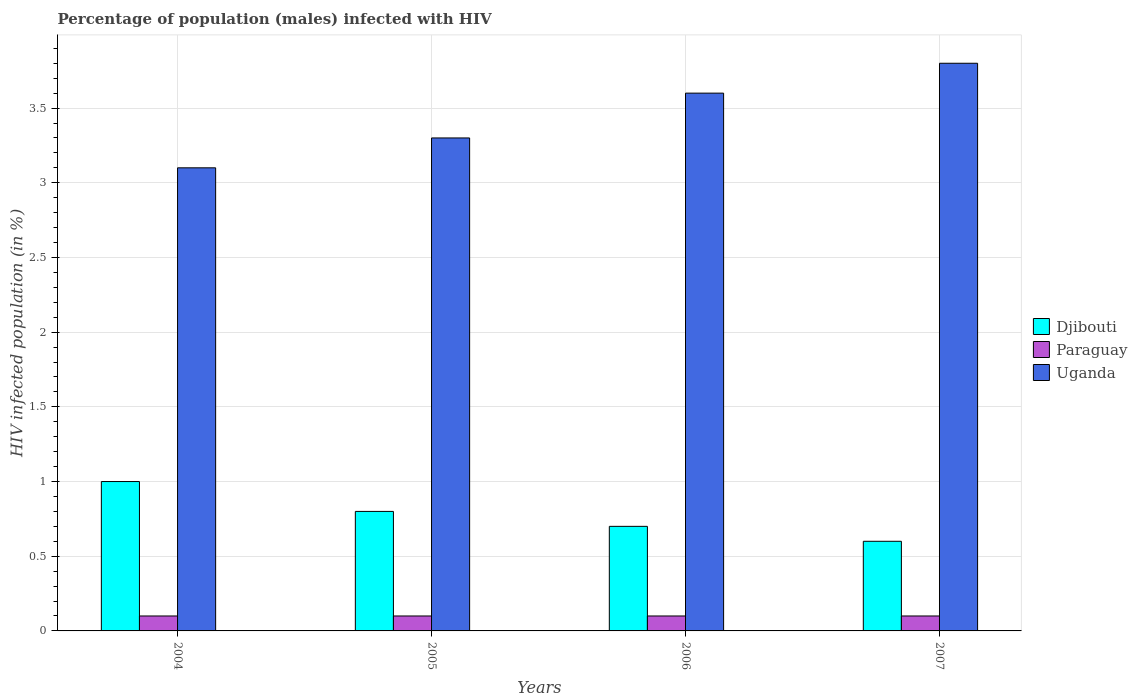How many groups of bars are there?
Provide a succinct answer. 4. How many bars are there on the 3rd tick from the left?
Ensure brevity in your answer.  3. How many bars are there on the 1st tick from the right?
Give a very brief answer. 3. In how many cases, is the number of bars for a given year not equal to the number of legend labels?
Offer a very short reply. 0. Across all years, what is the minimum percentage of HIV infected male population in Uganda?
Make the answer very short. 3.1. What is the difference between the percentage of HIV infected male population in Djibouti in 2004 and that in 2005?
Give a very brief answer. 0.2. What is the difference between the percentage of HIV infected male population in Uganda in 2007 and the percentage of HIV infected male population in Djibouti in 2006?
Ensure brevity in your answer.  3.1. What is the average percentage of HIV infected male population in Paraguay per year?
Offer a terse response. 0.1. What is the ratio of the percentage of HIV infected male population in Djibouti in 2004 to that in 2005?
Ensure brevity in your answer.  1.25. What is the difference between the highest and the second highest percentage of HIV infected male population in Djibouti?
Offer a very short reply. 0.2. What is the difference between the highest and the lowest percentage of HIV infected male population in Paraguay?
Ensure brevity in your answer.  0. In how many years, is the percentage of HIV infected male population in Paraguay greater than the average percentage of HIV infected male population in Paraguay taken over all years?
Ensure brevity in your answer.  0. Is the sum of the percentage of HIV infected male population in Djibouti in 2005 and 2006 greater than the maximum percentage of HIV infected male population in Paraguay across all years?
Your response must be concise. Yes. What does the 2nd bar from the left in 2007 represents?
Your response must be concise. Paraguay. What does the 2nd bar from the right in 2007 represents?
Keep it short and to the point. Paraguay. Is it the case that in every year, the sum of the percentage of HIV infected male population in Paraguay and percentage of HIV infected male population in Djibouti is greater than the percentage of HIV infected male population in Uganda?
Make the answer very short. No. How many bars are there?
Your answer should be very brief. 12. Are all the bars in the graph horizontal?
Offer a terse response. No. Are the values on the major ticks of Y-axis written in scientific E-notation?
Keep it short and to the point. No. Does the graph contain grids?
Your answer should be very brief. Yes. How are the legend labels stacked?
Provide a succinct answer. Vertical. What is the title of the graph?
Offer a terse response. Percentage of population (males) infected with HIV. Does "Bolivia" appear as one of the legend labels in the graph?
Your answer should be compact. No. What is the label or title of the Y-axis?
Provide a succinct answer. HIV infected population (in %). What is the HIV infected population (in %) of Djibouti in 2004?
Offer a very short reply. 1. What is the HIV infected population (in %) in Paraguay in 2004?
Offer a terse response. 0.1. What is the HIV infected population (in %) in Uganda in 2004?
Provide a short and direct response. 3.1. What is the HIV infected population (in %) in Paraguay in 2007?
Give a very brief answer. 0.1. What is the HIV infected population (in %) of Uganda in 2007?
Ensure brevity in your answer.  3.8. Across all years, what is the maximum HIV infected population (in %) of Djibouti?
Make the answer very short. 1. Across all years, what is the maximum HIV infected population (in %) of Paraguay?
Your answer should be compact. 0.1. Across all years, what is the minimum HIV infected population (in %) of Djibouti?
Your answer should be very brief. 0.6. What is the total HIV infected population (in %) in Djibouti in the graph?
Offer a terse response. 3.1. What is the total HIV infected population (in %) of Paraguay in the graph?
Offer a terse response. 0.4. What is the difference between the HIV infected population (in %) in Uganda in 2004 and that in 2005?
Keep it short and to the point. -0.2. What is the difference between the HIV infected population (in %) in Djibouti in 2004 and that in 2006?
Your answer should be very brief. 0.3. What is the difference between the HIV infected population (in %) of Paraguay in 2004 and that in 2006?
Ensure brevity in your answer.  0. What is the difference between the HIV infected population (in %) of Uganda in 2004 and that in 2006?
Your answer should be very brief. -0.5. What is the difference between the HIV infected population (in %) in Djibouti in 2004 and that in 2007?
Provide a short and direct response. 0.4. What is the difference between the HIV infected population (in %) of Uganda in 2004 and that in 2007?
Your answer should be very brief. -0.7. What is the difference between the HIV infected population (in %) of Paraguay in 2005 and that in 2006?
Give a very brief answer. 0. What is the difference between the HIV infected population (in %) of Uganda in 2005 and that in 2006?
Provide a succinct answer. -0.3. What is the difference between the HIV infected population (in %) of Djibouti in 2005 and that in 2007?
Ensure brevity in your answer.  0.2. What is the difference between the HIV infected population (in %) of Djibouti in 2006 and that in 2007?
Offer a terse response. 0.1. What is the difference between the HIV infected population (in %) of Uganda in 2006 and that in 2007?
Offer a very short reply. -0.2. What is the difference between the HIV infected population (in %) in Djibouti in 2004 and the HIV infected population (in %) in Paraguay in 2005?
Provide a succinct answer. 0.9. What is the difference between the HIV infected population (in %) in Djibouti in 2004 and the HIV infected population (in %) in Uganda in 2005?
Make the answer very short. -2.3. What is the difference between the HIV infected population (in %) of Djibouti in 2004 and the HIV infected population (in %) of Paraguay in 2006?
Offer a terse response. 0.9. What is the difference between the HIV infected population (in %) of Djibouti in 2004 and the HIV infected population (in %) of Uganda in 2006?
Ensure brevity in your answer.  -2.6. What is the difference between the HIV infected population (in %) in Djibouti in 2004 and the HIV infected population (in %) in Paraguay in 2007?
Make the answer very short. 0.9. What is the difference between the HIV infected population (in %) in Djibouti in 2004 and the HIV infected population (in %) in Uganda in 2007?
Give a very brief answer. -2.8. What is the difference between the HIV infected population (in %) of Paraguay in 2004 and the HIV infected population (in %) of Uganda in 2007?
Make the answer very short. -3.7. What is the difference between the HIV infected population (in %) in Djibouti in 2006 and the HIV infected population (in %) in Uganda in 2007?
Provide a short and direct response. -3.1. What is the average HIV infected population (in %) of Djibouti per year?
Provide a succinct answer. 0.78. What is the average HIV infected population (in %) of Uganda per year?
Ensure brevity in your answer.  3.45. In the year 2004, what is the difference between the HIV infected population (in %) in Djibouti and HIV infected population (in %) in Paraguay?
Your response must be concise. 0.9. In the year 2004, what is the difference between the HIV infected population (in %) of Paraguay and HIV infected population (in %) of Uganda?
Ensure brevity in your answer.  -3. In the year 2007, what is the difference between the HIV infected population (in %) of Djibouti and HIV infected population (in %) of Paraguay?
Ensure brevity in your answer.  0.5. In the year 2007, what is the difference between the HIV infected population (in %) in Djibouti and HIV infected population (in %) in Uganda?
Offer a terse response. -3.2. What is the ratio of the HIV infected population (in %) in Djibouti in 2004 to that in 2005?
Offer a very short reply. 1.25. What is the ratio of the HIV infected population (in %) in Paraguay in 2004 to that in 2005?
Provide a succinct answer. 1. What is the ratio of the HIV infected population (in %) of Uganda in 2004 to that in 2005?
Offer a very short reply. 0.94. What is the ratio of the HIV infected population (in %) of Djibouti in 2004 to that in 2006?
Provide a short and direct response. 1.43. What is the ratio of the HIV infected population (in %) in Paraguay in 2004 to that in 2006?
Keep it short and to the point. 1. What is the ratio of the HIV infected population (in %) of Uganda in 2004 to that in 2006?
Your answer should be very brief. 0.86. What is the ratio of the HIV infected population (in %) of Paraguay in 2004 to that in 2007?
Your answer should be very brief. 1. What is the ratio of the HIV infected population (in %) of Uganda in 2004 to that in 2007?
Your answer should be compact. 0.82. What is the ratio of the HIV infected population (in %) of Uganda in 2005 to that in 2006?
Your answer should be very brief. 0.92. What is the ratio of the HIV infected population (in %) of Djibouti in 2005 to that in 2007?
Ensure brevity in your answer.  1.33. What is the ratio of the HIV infected population (in %) of Uganda in 2005 to that in 2007?
Provide a succinct answer. 0.87. What is the ratio of the HIV infected population (in %) in Uganda in 2006 to that in 2007?
Your answer should be compact. 0.95. What is the difference between the highest and the second highest HIV infected population (in %) in Djibouti?
Ensure brevity in your answer.  0.2. What is the difference between the highest and the lowest HIV infected population (in %) of Djibouti?
Your answer should be compact. 0.4. 